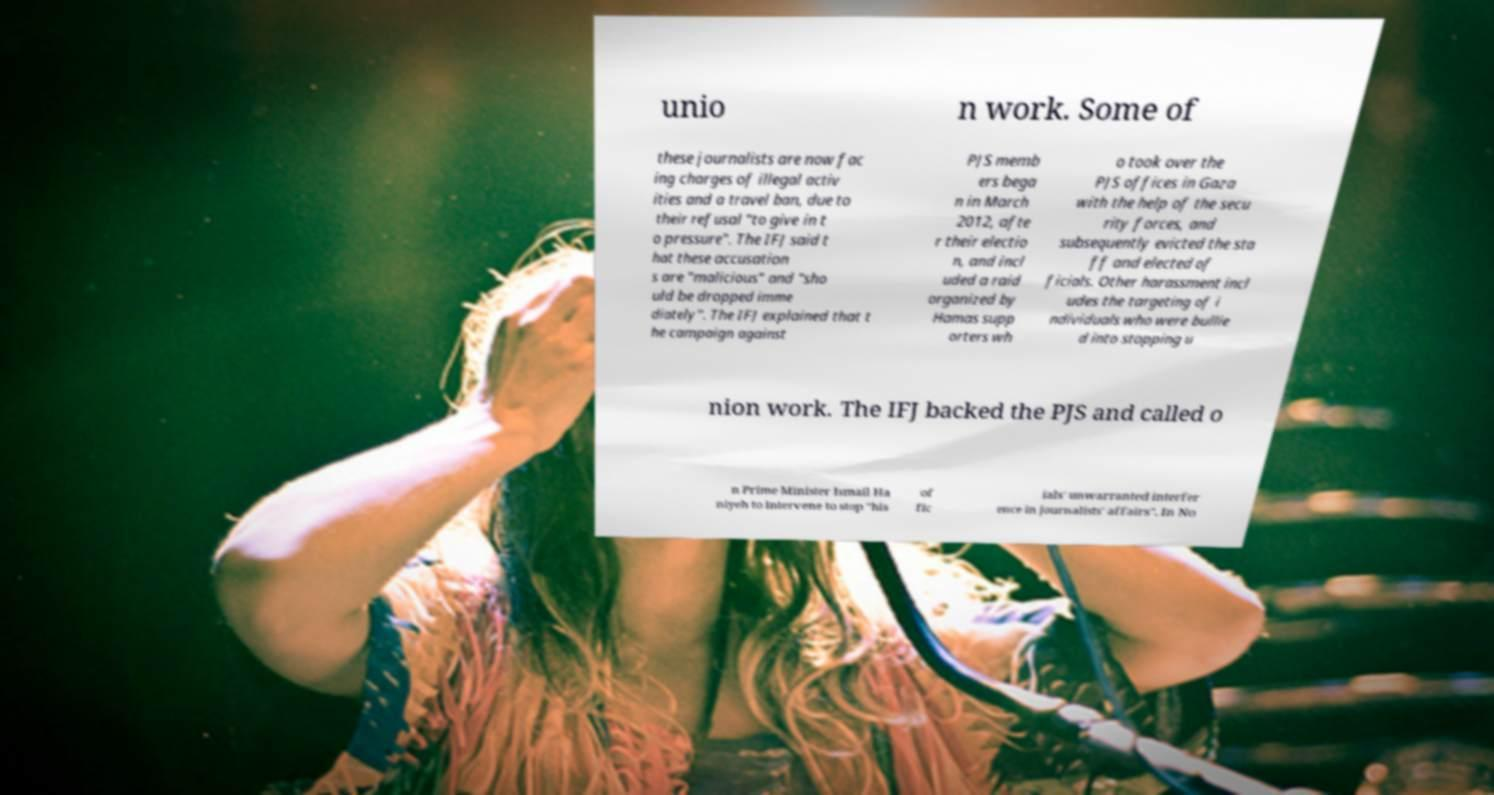Please identify and transcribe the text found in this image. unio n work. Some of these journalists are now fac ing charges of illegal activ ities and a travel ban, due to their refusal "to give in t o pressure". The IFJ said t hat these accusation s are "malicious" and "sho uld be dropped imme diately". The IFJ explained that t he campaign against PJS memb ers bega n in March 2012, afte r their electio n, and incl uded a raid organized by Hamas supp orters wh o took over the PJS offices in Gaza with the help of the secu rity forces, and subsequently evicted the sta ff and elected of ficials. Other harassment incl udes the targeting of i ndividuals who were bullie d into stopping u nion work. The IFJ backed the PJS and called o n Prime Minister Ismail Ha niyeh to intervene to stop "his of fic ials' unwarranted interfer ence in journalists' affairs". In No 